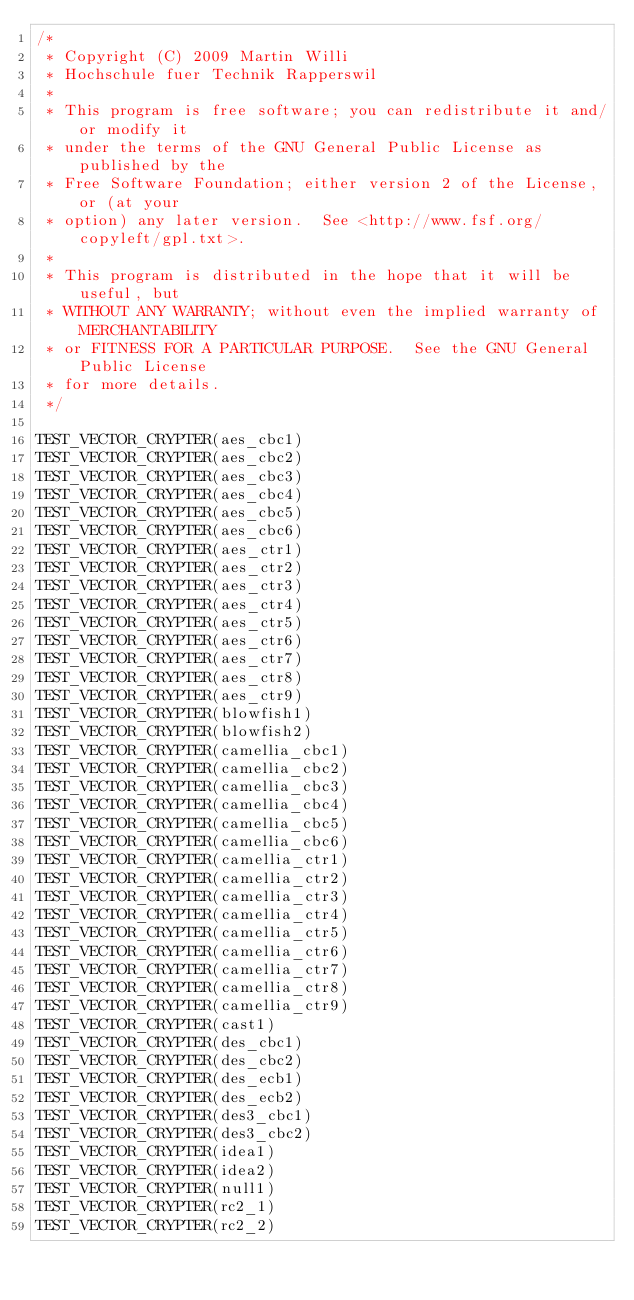Convert code to text. <code><loc_0><loc_0><loc_500><loc_500><_C_>/*
 * Copyright (C) 2009 Martin Willi
 * Hochschule fuer Technik Rapperswil
 *
 * This program is free software; you can redistribute it and/or modify it
 * under the terms of the GNU General Public License as published by the
 * Free Software Foundation; either version 2 of the License, or (at your
 * option) any later version.  See <http://www.fsf.org/copyleft/gpl.txt>.
 *
 * This program is distributed in the hope that it will be useful, but
 * WITHOUT ANY WARRANTY; without even the implied warranty of MERCHANTABILITY
 * or FITNESS FOR A PARTICULAR PURPOSE.  See the GNU General Public License
 * for more details.
 */

TEST_VECTOR_CRYPTER(aes_cbc1)
TEST_VECTOR_CRYPTER(aes_cbc2)
TEST_VECTOR_CRYPTER(aes_cbc3)
TEST_VECTOR_CRYPTER(aes_cbc4)
TEST_VECTOR_CRYPTER(aes_cbc5)
TEST_VECTOR_CRYPTER(aes_cbc6)
TEST_VECTOR_CRYPTER(aes_ctr1)
TEST_VECTOR_CRYPTER(aes_ctr2)
TEST_VECTOR_CRYPTER(aes_ctr3)
TEST_VECTOR_CRYPTER(aes_ctr4)
TEST_VECTOR_CRYPTER(aes_ctr5)
TEST_VECTOR_CRYPTER(aes_ctr6)
TEST_VECTOR_CRYPTER(aes_ctr7)
TEST_VECTOR_CRYPTER(aes_ctr8)
TEST_VECTOR_CRYPTER(aes_ctr9)
TEST_VECTOR_CRYPTER(blowfish1)
TEST_VECTOR_CRYPTER(blowfish2)
TEST_VECTOR_CRYPTER(camellia_cbc1)
TEST_VECTOR_CRYPTER(camellia_cbc2)
TEST_VECTOR_CRYPTER(camellia_cbc3)
TEST_VECTOR_CRYPTER(camellia_cbc4)
TEST_VECTOR_CRYPTER(camellia_cbc5)
TEST_VECTOR_CRYPTER(camellia_cbc6)
TEST_VECTOR_CRYPTER(camellia_ctr1)
TEST_VECTOR_CRYPTER(camellia_ctr2)
TEST_VECTOR_CRYPTER(camellia_ctr3)
TEST_VECTOR_CRYPTER(camellia_ctr4)
TEST_VECTOR_CRYPTER(camellia_ctr5)
TEST_VECTOR_CRYPTER(camellia_ctr6)
TEST_VECTOR_CRYPTER(camellia_ctr7)
TEST_VECTOR_CRYPTER(camellia_ctr8)
TEST_VECTOR_CRYPTER(camellia_ctr9)
TEST_VECTOR_CRYPTER(cast1)
TEST_VECTOR_CRYPTER(des_cbc1)
TEST_VECTOR_CRYPTER(des_cbc2)
TEST_VECTOR_CRYPTER(des_ecb1)
TEST_VECTOR_CRYPTER(des_ecb2)
TEST_VECTOR_CRYPTER(des3_cbc1)
TEST_VECTOR_CRYPTER(des3_cbc2)
TEST_VECTOR_CRYPTER(idea1)
TEST_VECTOR_CRYPTER(idea2)
TEST_VECTOR_CRYPTER(null1)
TEST_VECTOR_CRYPTER(rc2_1)
TEST_VECTOR_CRYPTER(rc2_2)</code> 